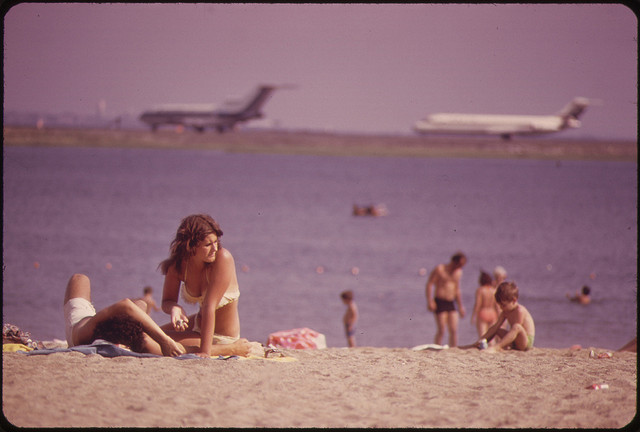What activities are the people engaged in at the beach? The individuals at the beach are involved in various activities: some are sunbathing and relaxing on towels, others appear to be enjoying the water, and a few can be seen walking along the shoreline. It's a typical leisurely day by the sea, under the watchful eye of incoming and departing flights nearby. 